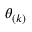Convert formula to latex. <formula><loc_0><loc_0><loc_500><loc_500>\theta _ { ( k ) }</formula> 